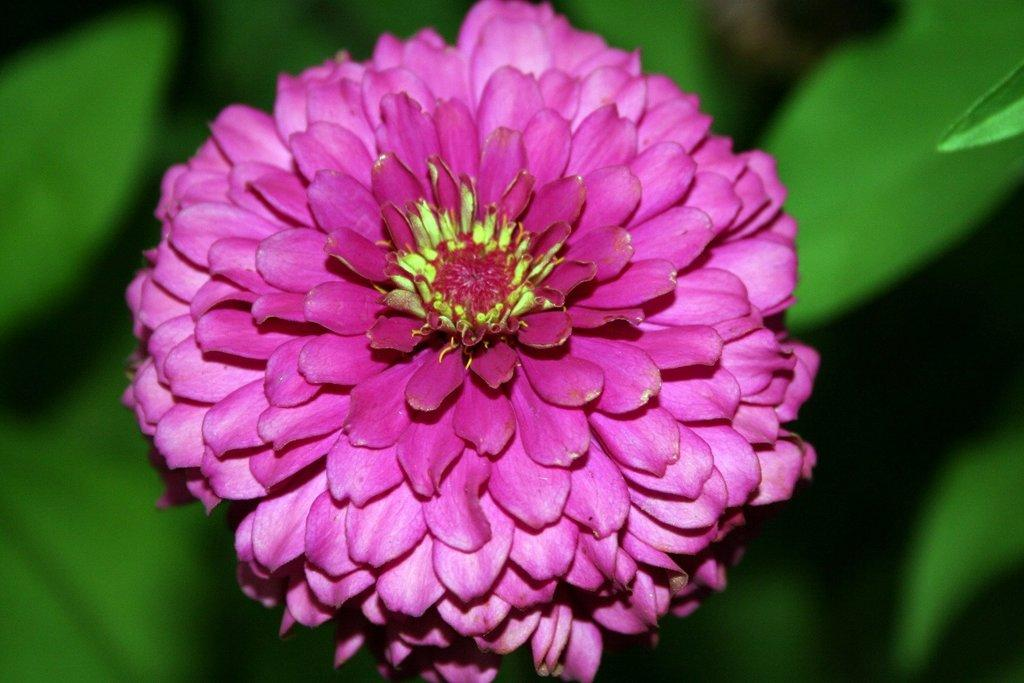What is the main subject in the foreground of the image? There is a pink color flower in the foreground of the image. Can you describe the background of the image? The background of the image is blurry. Is there any quicksand visible in the image? No, there is no quicksand present in the image. What rule can be seen written on a sign in the image? There is no sign or rule visible in the image. 